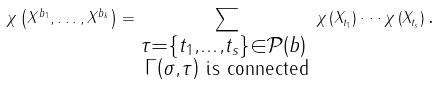<formula> <loc_0><loc_0><loc_500><loc_500>\chi \left ( X ^ { b _ { 1 } } , \dots , X ^ { b _ { k } } \right ) = \sum _ { \substack { \tau = \left \{ t _ { 1 } , \dots , t _ { s } \right \} \in \mathcal { P } \left ( b \right ) \text { } \\ \Gamma \left ( \sigma , \tau \right ) \text { is connected} } } \chi \left ( X _ { t _ { 1 } } \right ) \cdot \cdot \cdot \chi \left ( X _ { t _ { s } } \right ) \text {.}</formula> 